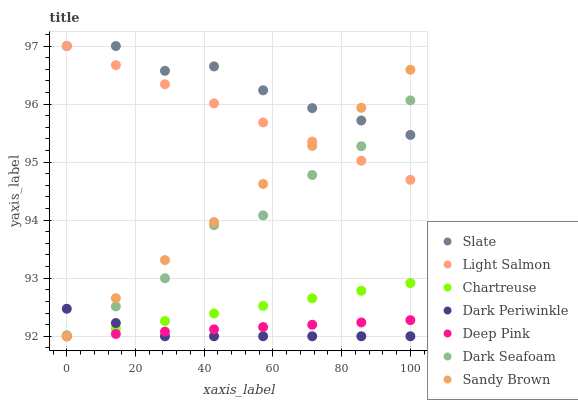Does Dark Periwinkle have the minimum area under the curve?
Answer yes or no. Yes. Does Slate have the maximum area under the curve?
Answer yes or no. Yes. Does Deep Pink have the minimum area under the curve?
Answer yes or no. No. Does Deep Pink have the maximum area under the curve?
Answer yes or no. No. Is Deep Pink the smoothest?
Answer yes or no. Yes. Is Dark Seafoam the roughest?
Answer yes or no. Yes. Is Slate the smoothest?
Answer yes or no. No. Is Slate the roughest?
Answer yes or no. No. Does Deep Pink have the lowest value?
Answer yes or no. Yes. Does Slate have the lowest value?
Answer yes or no. No. Does Slate have the highest value?
Answer yes or no. Yes. Does Deep Pink have the highest value?
Answer yes or no. No. Is Dark Periwinkle less than Slate?
Answer yes or no. Yes. Is Slate greater than Deep Pink?
Answer yes or no. Yes. Does Dark Periwinkle intersect Dark Seafoam?
Answer yes or no. Yes. Is Dark Periwinkle less than Dark Seafoam?
Answer yes or no. No. Is Dark Periwinkle greater than Dark Seafoam?
Answer yes or no. No. Does Dark Periwinkle intersect Slate?
Answer yes or no. No. 